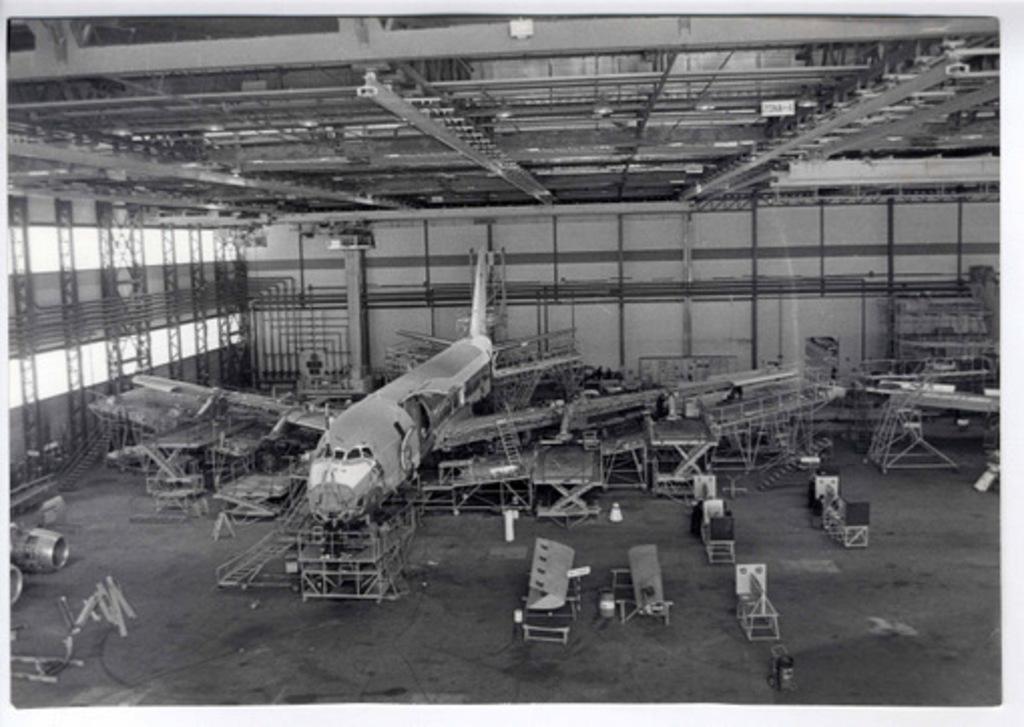In one or two sentences, can you explain what this image depicts? This is a black and white image, in this image there is a shed, inside the shed there is airplane and other parts. 